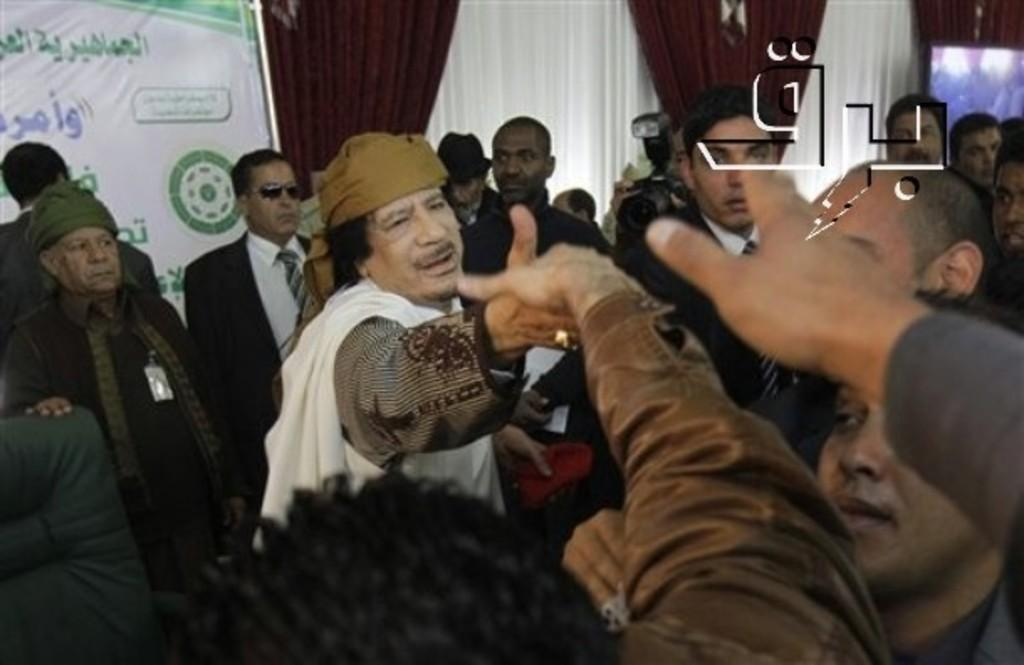What are the people in the image doing? Two people are shaking hands in the image. What else can be seen in the background of the image? There are curtains visible in the image. Is there any text present in the image? Yes, there is a board with text in the image. What type of test is being administered by the person holding the needle in the image? There is no person holding a needle in the image, and therefore no test is being administered. 